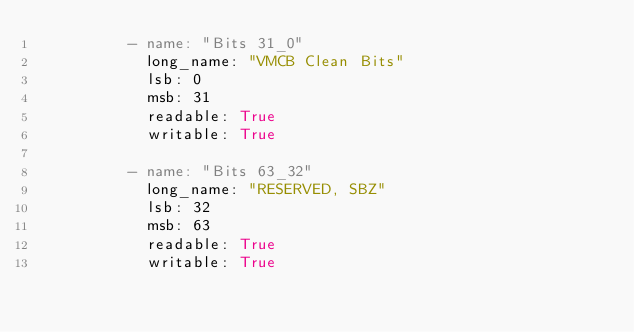<code> <loc_0><loc_0><loc_500><loc_500><_YAML_>          - name: "Bits 31_0"
            long_name: "VMCB Clean Bits" 
            lsb: 0
            msb: 31
            readable: True
            writable: True

          - name: "Bits 63_32"
            long_name: "RESERVED, SBZ" 
            lsb: 32
            msb: 63
            readable: True
            writable: True
</code> 